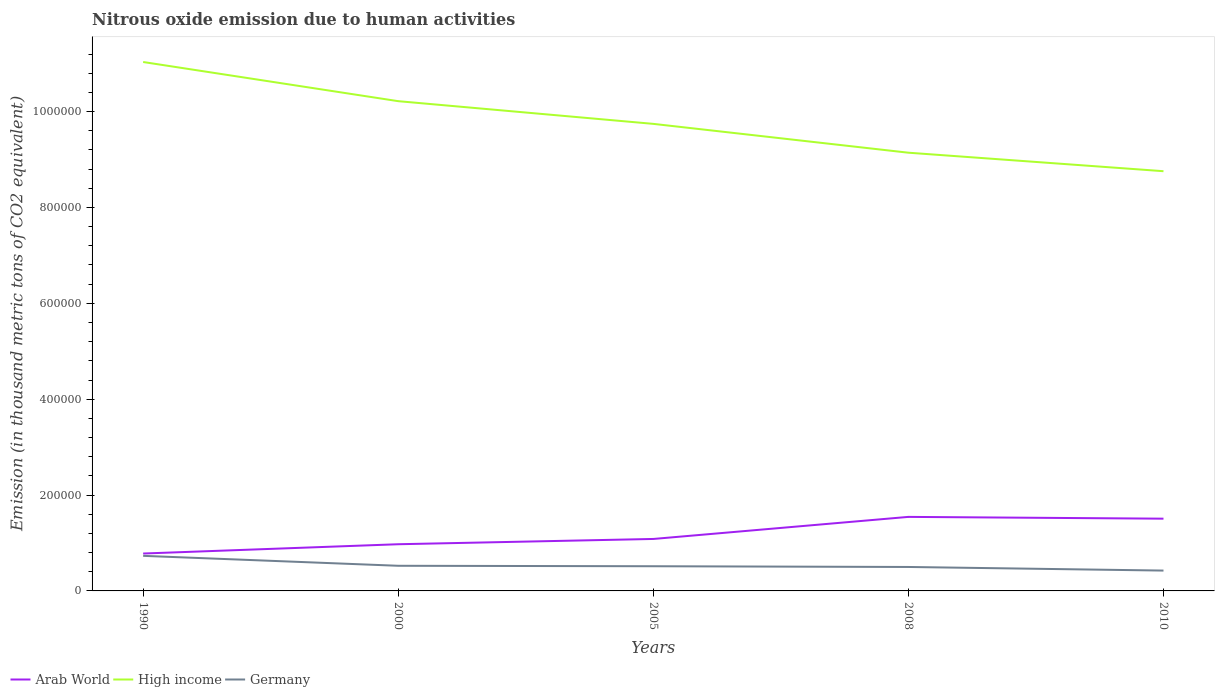How many different coloured lines are there?
Keep it short and to the point. 3. Does the line corresponding to Arab World intersect with the line corresponding to High income?
Provide a succinct answer. No. Is the number of lines equal to the number of legend labels?
Provide a short and direct response. Yes. Across all years, what is the maximum amount of nitrous oxide emitted in Arab World?
Your answer should be very brief. 7.80e+04. In which year was the amount of nitrous oxide emitted in High income maximum?
Your response must be concise. 2010. What is the total amount of nitrous oxide emitted in Germany in the graph?
Your response must be concise. 2493.2. What is the difference between the highest and the second highest amount of nitrous oxide emitted in Arab World?
Offer a very short reply. 7.64e+04. What is the difference between the highest and the lowest amount of nitrous oxide emitted in Germany?
Your response must be concise. 1. Is the amount of nitrous oxide emitted in Germany strictly greater than the amount of nitrous oxide emitted in Arab World over the years?
Make the answer very short. Yes. How many lines are there?
Your response must be concise. 3. How many years are there in the graph?
Give a very brief answer. 5. What is the difference between two consecutive major ticks on the Y-axis?
Give a very brief answer. 2.00e+05. Are the values on the major ticks of Y-axis written in scientific E-notation?
Keep it short and to the point. No. Does the graph contain any zero values?
Make the answer very short. No. Where does the legend appear in the graph?
Offer a terse response. Bottom left. How are the legend labels stacked?
Make the answer very short. Horizontal. What is the title of the graph?
Provide a succinct answer. Nitrous oxide emission due to human activities. What is the label or title of the Y-axis?
Your response must be concise. Emission (in thousand metric tons of CO2 equivalent). What is the Emission (in thousand metric tons of CO2 equivalent) in Arab World in 1990?
Ensure brevity in your answer.  7.80e+04. What is the Emission (in thousand metric tons of CO2 equivalent) in High income in 1990?
Your response must be concise. 1.10e+06. What is the Emission (in thousand metric tons of CO2 equivalent) in Germany in 1990?
Make the answer very short. 7.32e+04. What is the Emission (in thousand metric tons of CO2 equivalent) in Arab World in 2000?
Keep it short and to the point. 9.74e+04. What is the Emission (in thousand metric tons of CO2 equivalent) of High income in 2000?
Make the answer very short. 1.02e+06. What is the Emission (in thousand metric tons of CO2 equivalent) in Germany in 2000?
Provide a succinct answer. 5.25e+04. What is the Emission (in thousand metric tons of CO2 equivalent) in Arab World in 2005?
Keep it short and to the point. 1.08e+05. What is the Emission (in thousand metric tons of CO2 equivalent) in High income in 2005?
Give a very brief answer. 9.74e+05. What is the Emission (in thousand metric tons of CO2 equivalent) of Germany in 2005?
Ensure brevity in your answer.  5.15e+04. What is the Emission (in thousand metric tons of CO2 equivalent) of Arab World in 2008?
Give a very brief answer. 1.54e+05. What is the Emission (in thousand metric tons of CO2 equivalent) of High income in 2008?
Your answer should be very brief. 9.14e+05. What is the Emission (in thousand metric tons of CO2 equivalent) of Germany in 2008?
Offer a terse response. 5.00e+04. What is the Emission (in thousand metric tons of CO2 equivalent) in Arab World in 2010?
Provide a succinct answer. 1.51e+05. What is the Emission (in thousand metric tons of CO2 equivalent) of High income in 2010?
Ensure brevity in your answer.  8.76e+05. What is the Emission (in thousand metric tons of CO2 equivalent) in Germany in 2010?
Offer a terse response. 4.24e+04. Across all years, what is the maximum Emission (in thousand metric tons of CO2 equivalent) in Arab World?
Ensure brevity in your answer.  1.54e+05. Across all years, what is the maximum Emission (in thousand metric tons of CO2 equivalent) in High income?
Ensure brevity in your answer.  1.10e+06. Across all years, what is the maximum Emission (in thousand metric tons of CO2 equivalent) of Germany?
Offer a terse response. 7.32e+04. Across all years, what is the minimum Emission (in thousand metric tons of CO2 equivalent) in Arab World?
Your response must be concise. 7.80e+04. Across all years, what is the minimum Emission (in thousand metric tons of CO2 equivalent) in High income?
Your answer should be very brief. 8.76e+05. Across all years, what is the minimum Emission (in thousand metric tons of CO2 equivalent) of Germany?
Your response must be concise. 4.24e+04. What is the total Emission (in thousand metric tons of CO2 equivalent) of Arab World in the graph?
Provide a succinct answer. 5.89e+05. What is the total Emission (in thousand metric tons of CO2 equivalent) in High income in the graph?
Keep it short and to the point. 4.89e+06. What is the total Emission (in thousand metric tons of CO2 equivalent) in Germany in the graph?
Ensure brevity in your answer.  2.70e+05. What is the difference between the Emission (in thousand metric tons of CO2 equivalent) of Arab World in 1990 and that in 2000?
Provide a short and direct response. -1.94e+04. What is the difference between the Emission (in thousand metric tons of CO2 equivalent) of High income in 1990 and that in 2000?
Provide a short and direct response. 8.17e+04. What is the difference between the Emission (in thousand metric tons of CO2 equivalent) in Germany in 1990 and that in 2000?
Your response must be concise. 2.07e+04. What is the difference between the Emission (in thousand metric tons of CO2 equivalent) in Arab World in 1990 and that in 2005?
Make the answer very short. -3.04e+04. What is the difference between the Emission (in thousand metric tons of CO2 equivalent) in High income in 1990 and that in 2005?
Give a very brief answer. 1.29e+05. What is the difference between the Emission (in thousand metric tons of CO2 equivalent) in Germany in 1990 and that in 2005?
Keep it short and to the point. 2.17e+04. What is the difference between the Emission (in thousand metric tons of CO2 equivalent) of Arab World in 1990 and that in 2008?
Your answer should be compact. -7.64e+04. What is the difference between the Emission (in thousand metric tons of CO2 equivalent) of High income in 1990 and that in 2008?
Ensure brevity in your answer.  1.89e+05. What is the difference between the Emission (in thousand metric tons of CO2 equivalent) of Germany in 1990 and that in 2008?
Your response must be concise. 2.32e+04. What is the difference between the Emission (in thousand metric tons of CO2 equivalent) of Arab World in 1990 and that in 2010?
Offer a terse response. -7.27e+04. What is the difference between the Emission (in thousand metric tons of CO2 equivalent) in High income in 1990 and that in 2010?
Ensure brevity in your answer.  2.28e+05. What is the difference between the Emission (in thousand metric tons of CO2 equivalent) of Germany in 1990 and that in 2010?
Make the answer very short. 3.08e+04. What is the difference between the Emission (in thousand metric tons of CO2 equivalent) of Arab World in 2000 and that in 2005?
Give a very brief answer. -1.10e+04. What is the difference between the Emission (in thousand metric tons of CO2 equivalent) of High income in 2000 and that in 2005?
Give a very brief answer. 4.74e+04. What is the difference between the Emission (in thousand metric tons of CO2 equivalent) of Germany in 2000 and that in 2005?
Make the answer very short. 945.2. What is the difference between the Emission (in thousand metric tons of CO2 equivalent) of Arab World in 2000 and that in 2008?
Provide a succinct answer. -5.71e+04. What is the difference between the Emission (in thousand metric tons of CO2 equivalent) in High income in 2000 and that in 2008?
Keep it short and to the point. 1.08e+05. What is the difference between the Emission (in thousand metric tons of CO2 equivalent) in Germany in 2000 and that in 2008?
Provide a succinct answer. 2493.2. What is the difference between the Emission (in thousand metric tons of CO2 equivalent) of Arab World in 2000 and that in 2010?
Your answer should be compact. -5.33e+04. What is the difference between the Emission (in thousand metric tons of CO2 equivalent) of High income in 2000 and that in 2010?
Provide a short and direct response. 1.46e+05. What is the difference between the Emission (in thousand metric tons of CO2 equivalent) in Germany in 2000 and that in 2010?
Keep it short and to the point. 1.00e+04. What is the difference between the Emission (in thousand metric tons of CO2 equivalent) in Arab World in 2005 and that in 2008?
Keep it short and to the point. -4.61e+04. What is the difference between the Emission (in thousand metric tons of CO2 equivalent) of High income in 2005 and that in 2008?
Ensure brevity in your answer.  6.02e+04. What is the difference between the Emission (in thousand metric tons of CO2 equivalent) in Germany in 2005 and that in 2008?
Keep it short and to the point. 1548. What is the difference between the Emission (in thousand metric tons of CO2 equivalent) of Arab World in 2005 and that in 2010?
Provide a succinct answer. -4.23e+04. What is the difference between the Emission (in thousand metric tons of CO2 equivalent) of High income in 2005 and that in 2010?
Offer a very short reply. 9.88e+04. What is the difference between the Emission (in thousand metric tons of CO2 equivalent) in Germany in 2005 and that in 2010?
Keep it short and to the point. 9081.9. What is the difference between the Emission (in thousand metric tons of CO2 equivalent) of Arab World in 2008 and that in 2010?
Provide a short and direct response. 3741.4. What is the difference between the Emission (in thousand metric tons of CO2 equivalent) of High income in 2008 and that in 2010?
Provide a succinct answer. 3.86e+04. What is the difference between the Emission (in thousand metric tons of CO2 equivalent) in Germany in 2008 and that in 2010?
Provide a succinct answer. 7533.9. What is the difference between the Emission (in thousand metric tons of CO2 equivalent) in Arab World in 1990 and the Emission (in thousand metric tons of CO2 equivalent) in High income in 2000?
Ensure brevity in your answer.  -9.44e+05. What is the difference between the Emission (in thousand metric tons of CO2 equivalent) in Arab World in 1990 and the Emission (in thousand metric tons of CO2 equivalent) in Germany in 2000?
Offer a very short reply. 2.56e+04. What is the difference between the Emission (in thousand metric tons of CO2 equivalent) of High income in 1990 and the Emission (in thousand metric tons of CO2 equivalent) of Germany in 2000?
Provide a succinct answer. 1.05e+06. What is the difference between the Emission (in thousand metric tons of CO2 equivalent) in Arab World in 1990 and the Emission (in thousand metric tons of CO2 equivalent) in High income in 2005?
Offer a terse response. -8.96e+05. What is the difference between the Emission (in thousand metric tons of CO2 equivalent) in Arab World in 1990 and the Emission (in thousand metric tons of CO2 equivalent) in Germany in 2005?
Offer a terse response. 2.65e+04. What is the difference between the Emission (in thousand metric tons of CO2 equivalent) of High income in 1990 and the Emission (in thousand metric tons of CO2 equivalent) of Germany in 2005?
Provide a succinct answer. 1.05e+06. What is the difference between the Emission (in thousand metric tons of CO2 equivalent) in Arab World in 1990 and the Emission (in thousand metric tons of CO2 equivalent) in High income in 2008?
Offer a very short reply. -8.36e+05. What is the difference between the Emission (in thousand metric tons of CO2 equivalent) in Arab World in 1990 and the Emission (in thousand metric tons of CO2 equivalent) in Germany in 2008?
Make the answer very short. 2.81e+04. What is the difference between the Emission (in thousand metric tons of CO2 equivalent) in High income in 1990 and the Emission (in thousand metric tons of CO2 equivalent) in Germany in 2008?
Provide a succinct answer. 1.05e+06. What is the difference between the Emission (in thousand metric tons of CO2 equivalent) in Arab World in 1990 and the Emission (in thousand metric tons of CO2 equivalent) in High income in 2010?
Keep it short and to the point. -7.98e+05. What is the difference between the Emission (in thousand metric tons of CO2 equivalent) of Arab World in 1990 and the Emission (in thousand metric tons of CO2 equivalent) of Germany in 2010?
Offer a terse response. 3.56e+04. What is the difference between the Emission (in thousand metric tons of CO2 equivalent) in High income in 1990 and the Emission (in thousand metric tons of CO2 equivalent) in Germany in 2010?
Ensure brevity in your answer.  1.06e+06. What is the difference between the Emission (in thousand metric tons of CO2 equivalent) of Arab World in 2000 and the Emission (in thousand metric tons of CO2 equivalent) of High income in 2005?
Your answer should be very brief. -8.77e+05. What is the difference between the Emission (in thousand metric tons of CO2 equivalent) of Arab World in 2000 and the Emission (in thousand metric tons of CO2 equivalent) of Germany in 2005?
Provide a short and direct response. 4.59e+04. What is the difference between the Emission (in thousand metric tons of CO2 equivalent) of High income in 2000 and the Emission (in thousand metric tons of CO2 equivalent) of Germany in 2005?
Offer a very short reply. 9.70e+05. What is the difference between the Emission (in thousand metric tons of CO2 equivalent) of Arab World in 2000 and the Emission (in thousand metric tons of CO2 equivalent) of High income in 2008?
Provide a succinct answer. -8.17e+05. What is the difference between the Emission (in thousand metric tons of CO2 equivalent) of Arab World in 2000 and the Emission (in thousand metric tons of CO2 equivalent) of Germany in 2008?
Keep it short and to the point. 4.74e+04. What is the difference between the Emission (in thousand metric tons of CO2 equivalent) of High income in 2000 and the Emission (in thousand metric tons of CO2 equivalent) of Germany in 2008?
Your answer should be compact. 9.72e+05. What is the difference between the Emission (in thousand metric tons of CO2 equivalent) in Arab World in 2000 and the Emission (in thousand metric tons of CO2 equivalent) in High income in 2010?
Offer a very short reply. -7.78e+05. What is the difference between the Emission (in thousand metric tons of CO2 equivalent) of Arab World in 2000 and the Emission (in thousand metric tons of CO2 equivalent) of Germany in 2010?
Keep it short and to the point. 5.50e+04. What is the difference between the Emission (in thousand metric tons of CO2 equivalent) of High income in 2000 and the Emission (in thousand metric tons of CO2 equivalent) of Germany in 2010?
Your answer should be compact. 9.79e+05. What is the difference between the Emission (in thousand metric tons of CO2 equivalent) of Arab World in 2005 and the Emission (in thousand metric tons of CO2 equivalent) of High income in 2008?
Provide a short and direct response. -8.06e+05. What is the difference between the Emission (in thousand metric tons of CO2 equivalent) in Arab World in 2005 and the Emission (in thousand metric tons of CO2 equivalent) in Germany in 2008?
Your answer should be compact. 5.84e+04. What is the difference between the Emission (in thousand metric tons of CO2 equivalent) of High income in 2005 and the Emission (in thousand metric tons of CO2 equivalent) of Germany in 2008?
Offer a very short reply. 9.24e+05. What is the difference between the Emission (in thousand metric tons of CO2 equivalent) of Arab World in 2005 and the Emission (in thousand metric tons of CO2 equivalent) of High income in 2010?
Offer a terse response. -7.67e+05. What is the difference between the Emission (in thousand metric tons of CO2 equivalent) in Arab World in 2005 and the Emission (in thousand metric tons of CO2 equivalent) in Germany in 2010?
Offer a terse response. 6.60e+04. What is the difference between the Emission (in thousand metric tons of CO2 equivalent) of High income in 2005 and the Emission (in thousand metric tons of CO2 equivalent) of Germany in 2010?
Make the answer very short. 9.32e+05. What is the difference between the Emission (in thousand metric tons of CO2 equivalent) in Arab World in 2008 and the Emission (in thousand metric tons of CO2 equivalent) in High income in 2010?
Your answer should be compact. -7.21e+05. What is the difference between the Emission (in thousand metric tons of CO2 equivalent) of Arab World in 2008 and the Emission (in thousand metric tons of CO2 equivalent) of Germany in 2010?
Your answer should be compact. 1.12e+05. What is the difference between the Emission (in thousand metric tons of CO2 equivalent) of High income in 2008 and the Emission (in thousand metric tons of CO2 equivalent) of Germany in 2010?
Your answer should be compact. 8.72e+05. What is the average Emission (in thousand metric tons of CO2 equivalent) in Arab World per year?
Offer a very short reply. 1.18e+05. What is the average Emission (in thousand metric tons of CO2 equivalent) of High income per year?
Ensure brevity in your answer.  9.78e+05. What is the average Emission (in thousand metric tons of CO2 equivalent) of Germany per year?
Give a very brief answer. 5.39e+04. In the year 1990, what is the difference between the Emission (in thousand metric tons of CO2 equivalent) of Arab World and Emission (in thousand metric tons of CO2 equivalent) of High income?
Provide a succinct answer. -1.03e+06. In the year 1990, what is the difference between the Emission (in thousand metric tons of CO2 equivalent) of Arab World and Emission (in thousand metric tons of CO2 equivalent) of Germany?
Ensure brevity in your answer.  4835.4. In the year 1990, what is the difference between the Emission (in thousand metric tons of CO2 equivalent) of High income and Emission (in thousand metric tons of CO2 equivalent) of Germany?
Ensure brevity in your answer.  1.03e+06. In the year 2000, what is the difference between the Emission (in thousand metric tons of CO2 equivalent) of Arab World and Emission (in thousand metric tons of CO2 equivalent) of High income?
Provide a short and direct response. -9.24e+05. In the year 2000, what is the difference between the Emission (in thousand metric tons of CO2 equivalent) of Arab World and Emission (in thousand metric tons of CO2 equivalent) of Germany?
Your response must be concise. 4.49e+04. In the year 2000, what is the difference between the Emission (in thousand metric tons of CO2 equivalent) of High income and Emission (in thousand metric tons of CO2 equivalent) of Germany?
Keep it short and to the point. 9.69e+05. In the year 2005, what is the difference between the Emission (in thousand metric tons of CO2 equivalent) in Arab World and Emission (in thousand metric tons of CO2 equivalent) in High income?
Offer a terse response. -8.66e+05. In the year 2005, what is the difference between the Emission (in thousand metric tons of CO2 equivalent) in Arab World and Emission (in thousand metric tons of CO2 equivalent) in Germany?
Your answer should be compact. 5.69e+04. In the year 2005, what is the difference between the Emission (in thousand metric tons of CO2 equivalent) of High income and Emission (in thousand metric tons of CO2 equivalent) of Germany?
Offer a terse response. 9.23e+05. In the year 2008, what is the difference between the Emission (in thousand metric tons of CO2 equivalent) in Arab World and Emission (in thousand metric tons of CO2 equivalent) in High income?
Offer a terse response. -7.60e+05. In the year 2008, what is the difference between the Emission (in thousand metric tons of CO2 equivalent) in Arab World and Emission (in thousand metric tons of CO2 equivalent) in Germany?
Offer a very short reply. 1.05e+05. In the year 2008, what is the difference between the Emission (in thousand metric tons of CO2 equivalent) in High income and Emission (in thousand metric tons of CO2 equivalent) in Germany?
Your answer should be compact. 8.64e+05. In the year 2010, what is the difference between the Emission (in thousand metric tons of CO2 equivalent) in Arab World and Emission (in thousand metric tons of CO2 equivalent) in High income?
Ensure brevity in your answer.  -7.25e+05. In the year 2010, what is the difference between the Emission (in thousand metric tons of CO2 equivalent) in Arab World and Emission (in thousand metric tons of CO2 equivalent) in Germany?
Offer a terse response. 1.08e+05. In the year 2010, what is the difference between the Emission (in thousand metric tons of CO2 equivalent) of High income and Emission (in thousand metric tons of CO2 equivalent) of Germany?
Provide a succinct answer. 8.33e+05. What is the ratio of the Emission (in thousand metric tons of CO2 equivalent) of Arab World in 1990 to that in 2000?
Keep it short and to the point. 0.8. What is the ratio of the Emission (in thousand metric tons of CO2 equivalent) of Germany in 1990 to that in 2000?
Keep it short and to the point. 1.4. What is the ratio of the Emission (in thousand metric tons of CO2 equivalent) in Arab World in 1990 to that in 2005?
Provide a short and direct response. 0.72. What is the ratio of the Emission (in thousand metric tons of CO2 equivalent) of High income in 1990 to that in 2005?
Offer a terse response. 1.13. What is the ratio of the Emission (in thousand metric tons of CO2 equivalent) in Germany in 1990 to that in 2005?
Offer a very short reply. 1.42. What is the ratio of the Emission (in thousand metric tons of CO2 equivalent) in Arab World in 1990 to that in 2008?
Your answer should be compact. 0.51. What is the ratio of the Emission (in thousand metric tons of CO2 equivalent) of High income in 1990 to that in 2008?
Your answer should be very brief. 1.21. What is the ratio of the Emission (in thousand metric tons of CO2 equivalent) of Germany in 1990 to that in 2008?
Your answer should be very brief. 1.46. What is the ratio of the Emission (in thousand metric tons of CO2 equivalent) in Arab World in 1990 to that in 2010?
Make the answer very short. 0.52. What is the ratio of the Emission (in thousand metric tons of CO2 equivalent) in High income in 1990 to that in 2010?
Your answer should be very brief. 1.26. What is the ratio of the Emission (in thousand metric tons of CO2 equivalent) in Germany in 1990 to that in 2010?
Provide a short and direct response. 1.72. What is the ratio of the Emission (in thousand metric tons of CO2 equivalent) in Arab World in 2000 to that in 2005?
Keep it short and to the point. 0.9. What is the ratio of the Emission (in thousand metric tons of CO2 equivalent) in High income in 2000 to that in 2005?
Ensure brevity in your answer.  1.05. What is the ratio of the Emission (in thousand metric tons of CO2 equivalent) in Germany in 2000 to that in 2005?
Keep it short and to the point. 1.02. What is the ratio of the Emission (in thousand metric tons of CO2 equivalent) in Arab World in 2000 to that in 2008?
Offer a very short reply. 0.63. What is the ratio of the Emission (in thousand metric tons of CO2 equivalent) in High income in 2000 to that in 2008?
Provide a short and direct response. 1.12. What is the ratio of the Emission (in thousand metric tons of CO2 equivalent) of Germany in 2000 to that in 2008?
Your response must be concise. 1.05. What is the ratio of the Emission (in thousand metric tons of CO2 equivalent) of Arab World in 2000 to that in 2010?
Your response must be concise. 0.65. What is the ratio of the Emission (in thousand metric tons of CO2 equivalent) in High income in 2000 to that in 2010?
Keep it short and to the point. 1.17. What is the ratio of the Emission (in thousand metric tons of CO2 equivalent) of Germany in 2000 to that in 2010?
Your answer should be compact. 1.24. What is the ratio of the Emission (in thousand metric tons of CO2 equivalent) in Arab World in 2005 to that in 2008?
Offer a very short reply. 0.7. What is the ratio of the Emission (in thousand metric tons of CO2 equivalent) of High income in 2005 to that in 2008?
Give a very brief answer. 1.07. What is the ratio of the Emission (in thousand metric tons of CO2 equivalent) of Germany in 2005 to that in 2008?
Keep it short and to the point. 1.03. What is the ratio of the Emission (in thousand metric tons of CO2 equivalent) in Arab World in 2005 to that in 2010?
Provide a succinct answer. 0.72. What is the ratio of the Emission (in thousand metric tons of CO2 equivalent) in High income in 2005 to that in 2010?
Offer a very short reply. 1.11. What is the ratio of the Emission (in thousand metric tons of CO2 equivalent) in Germany in 2005 to that in 2010?
Offer a terse response. 1.21. What is the ratio of the Emission (in thousand metric tons of CO2 equivalent) of Arab World in 2008 to that in 2010?
Ensure brevity in your answer.  1.02. What is the ratio of the Emission (in thousand metric tons of CO2 equivalent) of High income in 2008 to that in 2010?
Your response must be concise. 1.04. What is the ratio of the Emission (in thousand metric tons of CO2 equivalent) of Germany in 2008 to that in 2010?
Keep it short and to the point. 1.18. What is the difference between the highest and the second highest Emission (in thousand metric tons of CO2 equivalent) in Arab World?
Offer a terse response. 3741.4. What is the difference between the highest and the second highest Emission (in thousand metric tons of CO2 equivalent) in High income?
Give a very brief answer. 8.17e+04. What is the difference between the highest and the second highest Emission (in thousand metric tons of CO2 equivalent) of Germany?
Offer a terse response. 2.07e+04. What is the difference between the highest and the lowest Emission (in thousand metric tons of CO2 equivalent) of Arab World?
Make the answer very short. 7.64e+04. What is the difference between the highest and the lowest Emission (in thousand metric tons of CO2 equivalent) in High income?
Provide a short and direct response. 2.28e+05. What is the difference between the highest and the lowest Emission (in thousand metric tons of CO2 equivalent) in Germany?
Provide a succinct answer. 3.08e+04. 